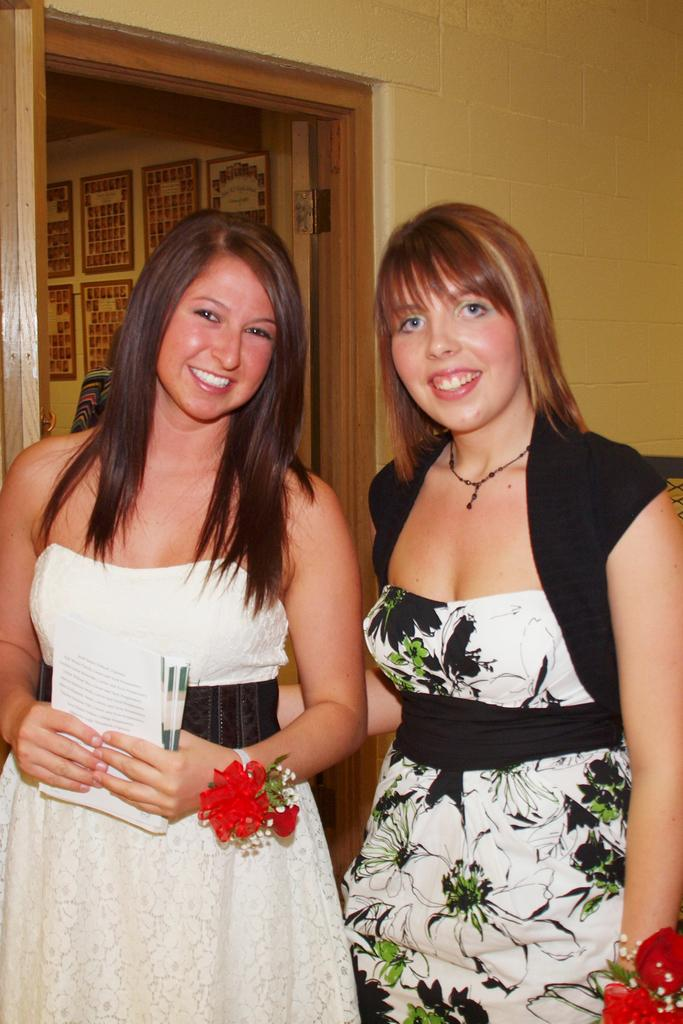What can be seen in the image? There are flowers, two women standing and smiling, and frames visible in the background. What are the women holding in the image? One woman is holding books with her hands. What can be seen in the background of the image? There are frames, walls, and a person visible in the background. What type of noise can be heard coming from the queen in the image? There is no queen present in the image, and therefore no noise can be heard from her. Is the dad visible in the image? The provided facts do not mention a dad, so it cannot be determined if a dad is present in the image. 